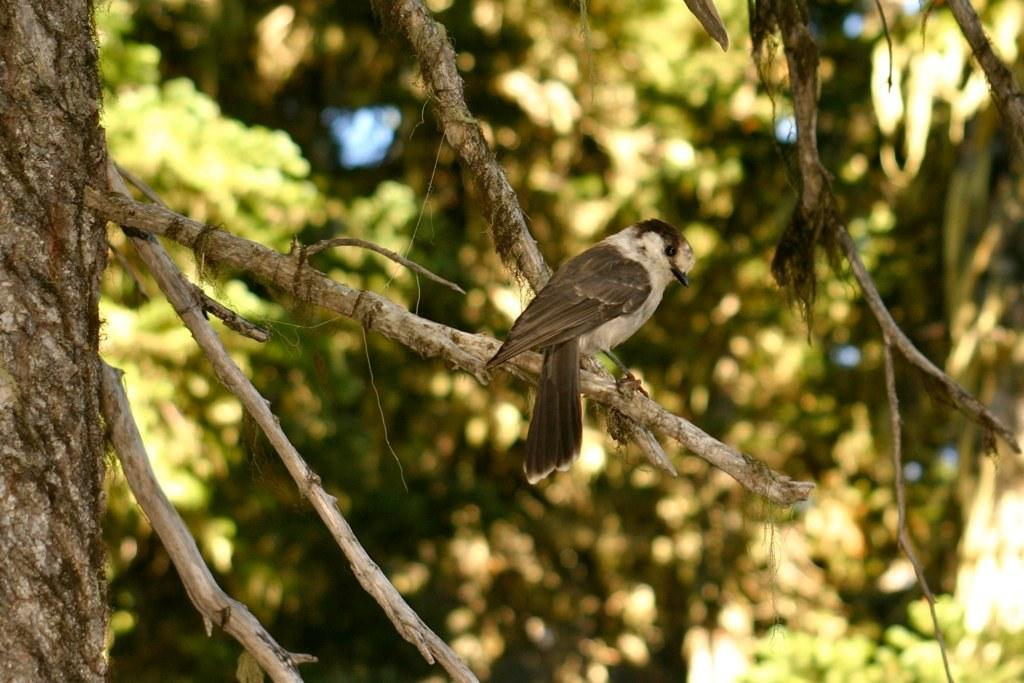What is the main object in the foreground of the image? There is a branch of a tree in the image. What can be seen in the distance behind the branch? There are trees visible in the background of the image. How would you describe the appearance of the background in the image? The background of the image is blurry. What type of credit card is visible in the image? There is no credit card present in the image. How many wheels does the stick have in the image? There is no stick present in the image, and therefore no wheels can be counted. 